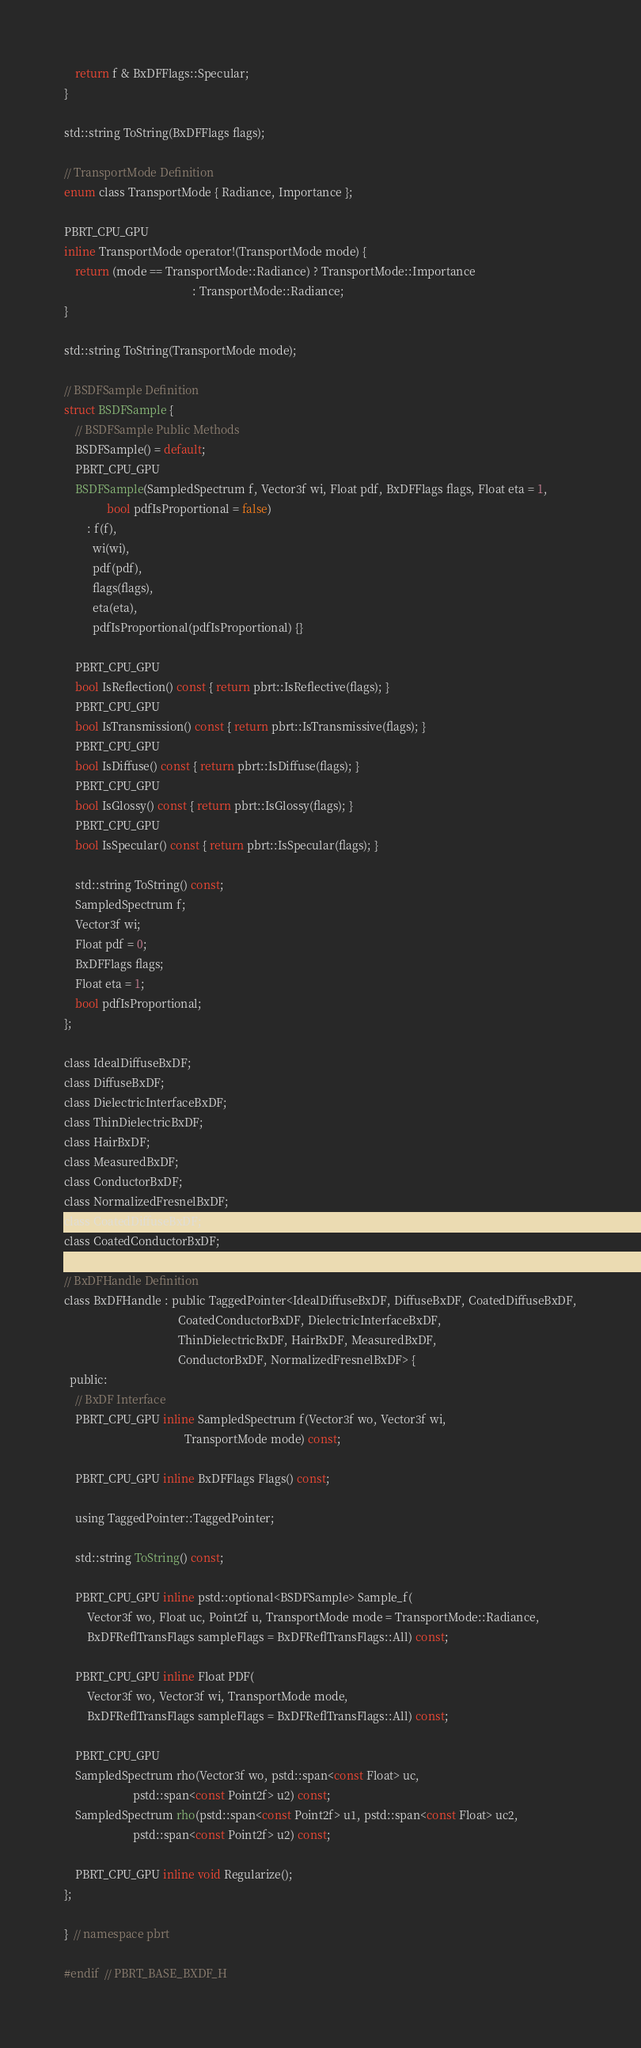<code> <loc_0><loc_0><loc_500><loc_500><_C_>    return f & BxDFFlags::Specular;
}

std::string ToString(BxDFFlags flags);

// TransportMode Definition
enum class TransportMode { Radiance, Importance };

PBRT_CPU_GPU
inline TransportMode operator!(TransportMode mode) {
    return (mode == TransportMode::Radiance) ? TransportMode::Importance
                                             : TransportMode::Radiance;
}

std::string ToString(TransportMode mode);

// BSDFSample Definition
struct BSDFSample {
    // BSDFSample Public Methods
    BSDFSample() = default;
    PBRT_CPU_GPU
    BSDFSample(SampledSpectrum f, Vector3f wi, Float pdf, BxDFFlags flags, Float eta = 1,
               bool pdfIsProportional = false)
        : f(f),
          wi(wi),
          pdf(pdf),
          flags(flags),
          eta(eta),
          pdfIsProportional(pdfIsProportional) {}

    PBRT_CPU_GPU
    bool IsReflection() const { return pbrt::IsReflective(flags); }
    PBRT_CPU_GPU
    bool IsTransmission() const { return pbrt::IsTransmissive(flags); }
    PBRT_CPU_GPU
    bool IsDiffuse() const { return pbrt::IsDiffuse(flags); }
    PBRT_CPU_GPU
    bool IsGlossy() const { return pbrt::IsGlossy(flags); }
    PBRT_CPU_GPU
    bool IsSpecular() const { return pbrt::IsSpecular(flags); }

    std::string ToString() const;
    SampledSpectrum f;
    Vector3f wi;
    Float pdf = 0;
    BxDFFlags flags;
    Float eta = 1;
    bool pdfIsProportional;
};

class IdealDiffuseBxDF;
class DiffuseBxDF;
class DielectricInterfaceBxDF;
class ThinDielectricBxDF;
class HairBxDF;
class MeasuredBxDF;
class ConductorBxDF;
class NormalizedFresnelBxDF;
class CoatedDiffuseBxDF;
class CoatedConductorBxDF;

// BxDFHandle Definition
class BxDFHandle : public TaggedPointer<IdealDiffuseBxDF, DiffuseBxDF, CoatedDiffuseBxDF,
                                        CoatedConductorBxDF, DielectricInterfaceBxDF,
                                        ThinDielectricBxDF, HairBxDF, MeasuredBxDF,
                                        ConductorBxDF, NormalizedFresnelBxDF> {
  public:
    // BxDF Interface
    PBRT_CPU_GPU inline SampledSpectrum f(Vector3f wo, Vector3f wi,
                                          TransportMode mode) const;

    PBRT_CPU_GPU inline BxDFFlags Flags() const;

    using TaggedPointer::TaggedPointer;

    std::string ToString() const;

    PBRT_CPU_GPU inline pstd::optional<BSDFSample> Sample_f(
        Vector3f wo, Float uc, Point2f u, TransportMode mode = TransportMode::Radiance,
        BxDFReflTransFlags sampleFlags = BxDFReflTransFlags::All) const;

    PBRT_CPU_GPU inline Float PDF(
        Vector3f wo, Vector3f wi, TransportMode mode,
        BxDFReflTransFlags sampleFlags = BxDFReflTransFlags::All) const;

    PBRT_CPU_GPU
    SampledSpectrum rho(Vector3f wo, pstd::span<const Float> uc,
                        pstd::span<const Point2f> u2) const;
    SampledSpectrum rho(pstd::span<const Point2f> u1, pstd::span<const Float> uc2,
                        pstd::span<const Point2f> u2) const;

    PBRT_CPU_GPU inline void Regularize();
};

}  // namespace pbrt

#endif  // PBRT_BASE_BXDF_H
</code> 